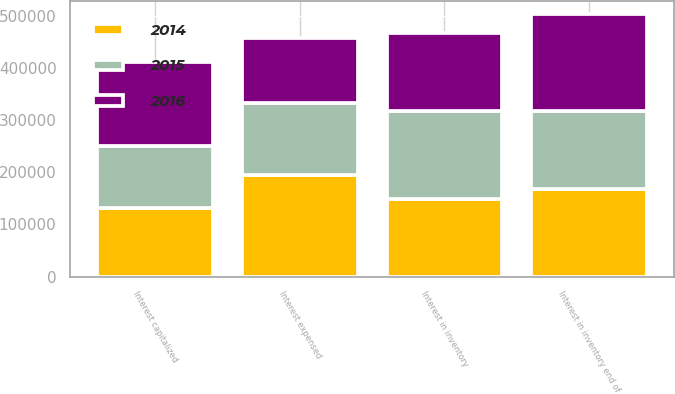Convert chart to OTSL. <chart><loc_0><loc_0><loc_500><loc_500><stacked_bar_chart><ecel><fcel>Interest in inventory<fcel>Interest capitalized<fcel>Interest expensed<fcel>Interest in inventory end of<nl><fcel>2016<fcel>149498<fcel>160506<fcel>123907<fcel>186097<nl><fcel>2015<fcel>167638<fcel>120001<fcel>138141<fcel>149498<nl><fcel>2014<fcel>149498<fcel>131444<fcel>194728<fcel>167638<nl></chart> 